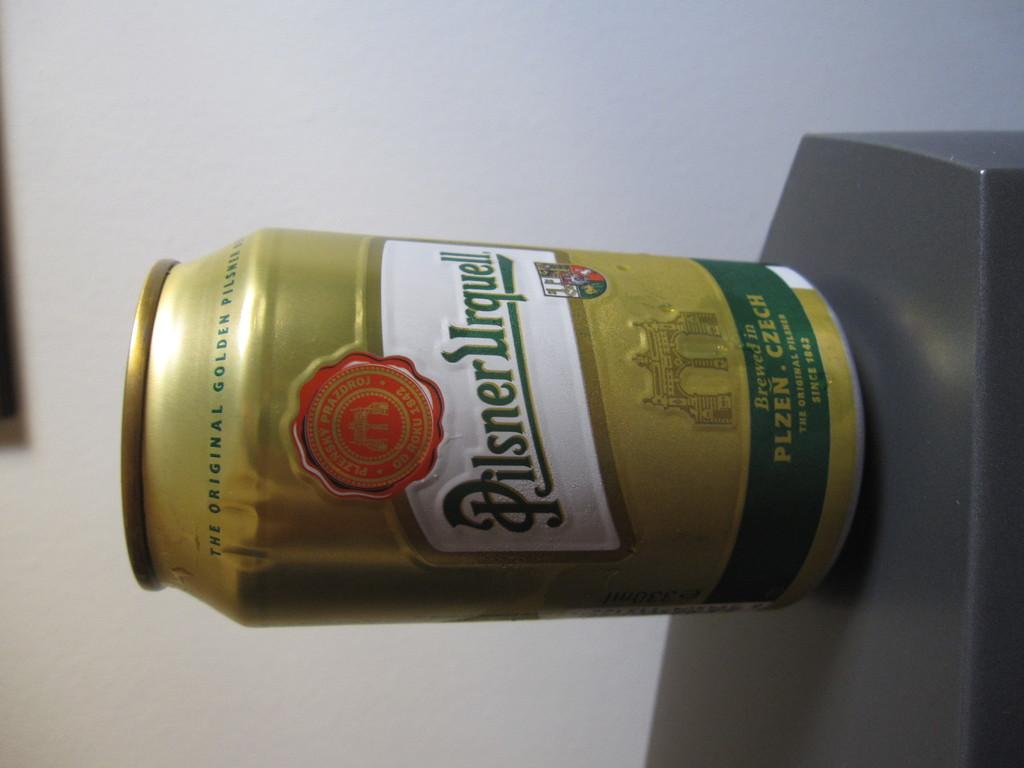<image>
Present a compact description of the photo's key features. A can of Pilsner Urquell sits on a dark surface. 